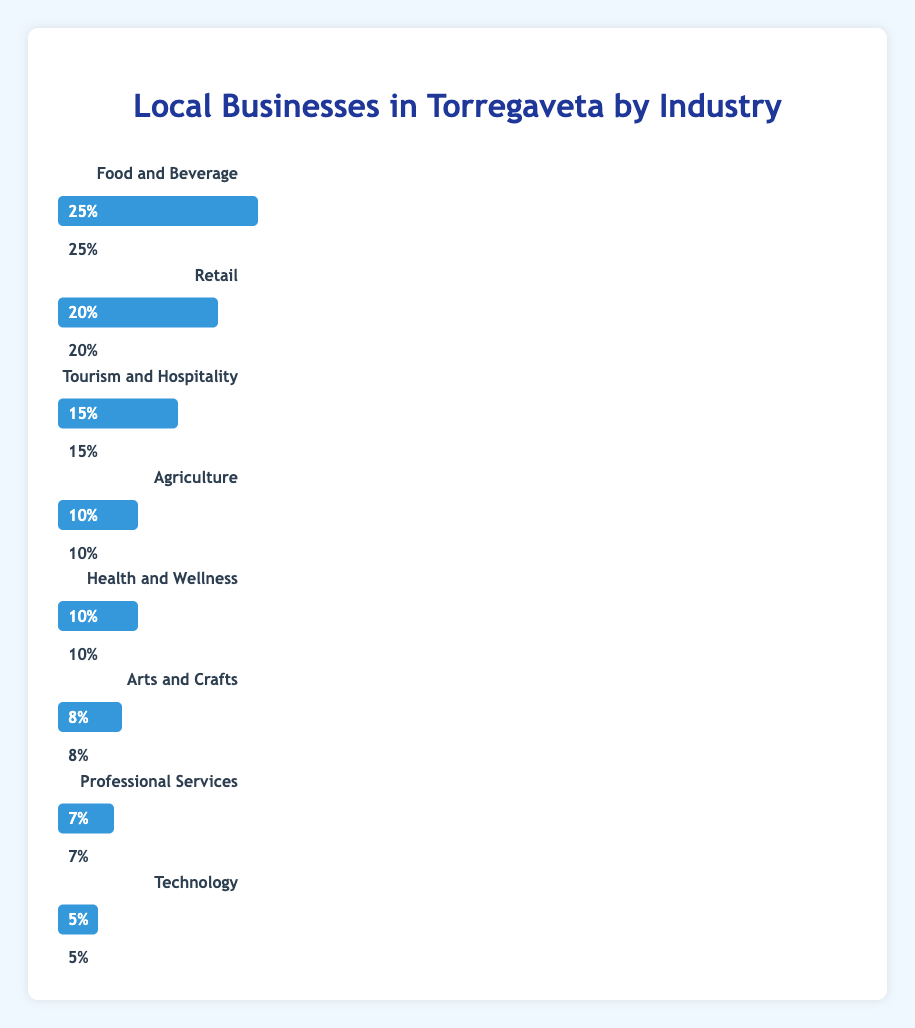What is the total percentage of businesses in the Food and Beverage, Retail, and Tourism and Hospitality industries? The percentage of businesses in the Food and Beverage, Retail, and Tourism and Hospitality industries are 25%, 20%, and 15% respectively. Adding these percentages gives us 25% + 20% + 15% = 60%.
Answer: 60% Which industries have an equal percentage of local businesses in Torregaveta? The chart shows that both Agriculture and Health and Wellness industries have 10% of local businesses each.
Answer: Agriculture and Health and Wellness What is the difference in percentage between the highest and lowest represented industries? The highest represented industry is Food and Beverage with 25%. The lowest represented industry is Technology with 5%. The difference is 25% - 5% which equals 20%.
Answer: 20% How many industries have a percentage of local businesses that is greater than 10%? The industries with a percentage greater than 10% are Food and Beverage (25%) and Retail (20%). Tourism and Hospitality is exactly 15%, which totals to three industries.
Answer: Three If Agriculture and Health and Wellness are combined into one category, what would be the new percentage for this category? Agriculture and Health and Wellness both have a 10% share each. Combining them, we get 10% + 10% which equals 20%.
Answer: 20% What is the percentage difference between Retail and Professional Services? Retail has a percentage of 20%, and Professional Services has 7%. The difference is calculated as 20% - 7% = 13%.
Answer: 13% Which industry has the second-highest percentage of local businesses? The industry with the second-highest percentage is Retail, with 20%.
Answer: Retail How does the length of the bars for Agriculture and Technology compare visually? The bar for Agriculture is twice the length of the bar for Technology. Agriculture is 10%, and Technology is 5%.
Answer: Agriculture's bar is twice as long as Technology's If you added the percentage of Arts and Crafts to Technology, what would be the combined percentage? Arts and Crafts account for 8%, and Technology accounts for 5%. Adding these together, we get 8% + 5% = 13%.
Answer: 13% Between Health and Wellness and Professional Services, which industry has a higher percentage, and by how much? Health and Wellness has 10%, while Professional Services has 7%. The difference is 10% - 7% = 3%.
Answer: Health and Wellness by 3% 